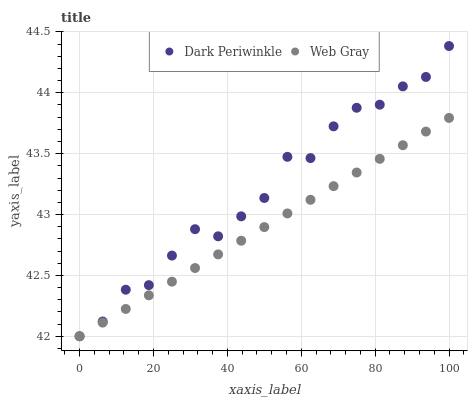Does Web Gray have the minimum area under the curve?
Answer yes or no. Yes. Does Dark Periwinkle have the maximum area under the curve?
Answer yes or no. Yes. Does Dark Periwinkle have the minimum area under the curve?
Answer yes or no. No. Is Web Gray the smoothest?
Answer yes or no. Yes. Is Dark Periwinkle the roughest?
Answer yes or no. Yes. Is Dark Periwinkle the smoothest?
Answer yes or no. No. Does Web Gray have the lowest value?
Answer yes or no. Yes. Does Dark Periwinkle have the highest value?
Answer yes or no. Yes. Does Web Gray intersect Dark Periwinkle?
Answer yes or no. Yes. Is Web Gray less than Dark Periwinkle?
Answer yes or no. No. Is Web Gray greater than Dark Periwinkle?
Answer yes or no. No. 